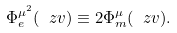<formula> <loc_0><loc_0><loc_500><loc_500>\Phi _ { e } ^ { \mu ^ { 2 } } ( \ z v ) \equiv 2 \Phi _ { m } ^ { \mu } ( \ z v ) .</formula> 